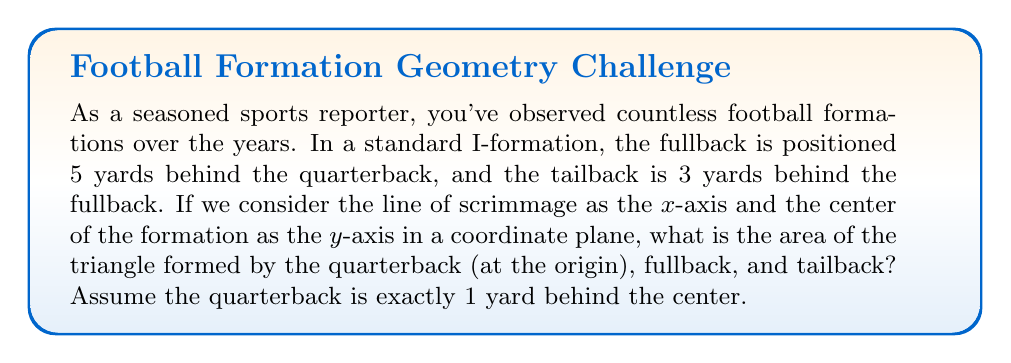Provide a solution to this math problem. Let's approach this step-by-step:

1) First, we need to establish the coordinates of each player:
   - Quarterback: (0, -1)
   - Fullback: (0, -6) [5 yards behind QB, which is 6 yards behind line of scrimmage]
   - Tailback: (0, -9) [3 yards behind fullback, which is 9 yards behind line of scrimmage]

2) Now we have a triangle with vertices at (0, -1), (0, -6), and (0, -9).

3) To find the area of this triangle, we can use the formula:
   $$A = \frac{1}{2}|x_1(y_2 - y_3) + x_2(y_3 - y_1) + x_3(y_1 - y_2)|$$

4) Substituting our coordinates:
   $$A = \frac{1}{2}|0(-6 - (-9)) + 0(-9 - (-1)) + 0(-1 - (-6))|$$

5) Simplifying:
   $$A = \frac{1}{2}|0(3) + 0(-8) + 0(5)| = 0$$

6) However, this result of 0 is because all points lie on the same vertical line, creating a degenerate triangle with no area.

7) To find the actual area, we need to consider the base and height of the triangle:
   - Base: distance between QB and tailback = 9 - 1 = 8 yards
   - Height: 0 (as all points are on the same line)

8) Area of a triangle: $$A = \frac{1}{2} \times base \times height$$

9) Substituting our values:
   $$A = \frac{1}{2} \times 8 \times 0 = 0$$

Therefore, the area of the triangle is 0 square yards.
Answer: 0 square yards 